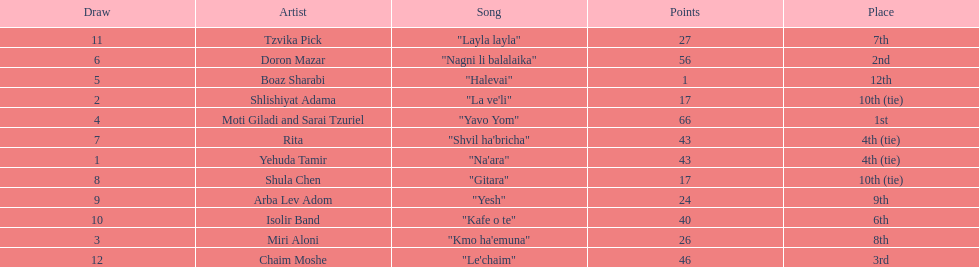Could you parse the entire table? {'header': ['Draw', 'Artist', 'Song', 'Points', 'Place'], 'rows': [['11', 'Tzvika Pick', '"Layla layla"', '27', '7th'], ['6', 'Doron Mazar', '"Nagni li balalaika"', '56', '2nd'], ['5', 'Boaz Sharabi', '"Halevai"', '1', '12th'], ['2', 'Shlishiyat Adama', '"La ve\'li"', '17', '10th (tie)'], ['4', 'Moti Giladi and Sarai Tzuriel', '"Yavo Yom"', '66', '1st'], ['7', 'Rita', '"Shvil ha\'bricha"', '43', '4th (tie)'], ['1', 'Yehuda Tamir', '"Na\'ara"', '43', '4th (tie)'], ['8', 'Shula Chen', '"Gitara"', '17', '10th (tie)'], ['9', 'Arba Lev Adom', '"Yesh"', '24', '9th'], ['10', 'Isolir Band', '"Kafe o te"', '40', '6th'], ['3', 'Miri Aloni', '"Kmo ha\'emuna"', '26', '8th'], ['12', 'Chaim Moshe', '"Le\'chaim"', '46', '3rd']]} What song is listed in the table right before layla layla? "Kafe o te". 